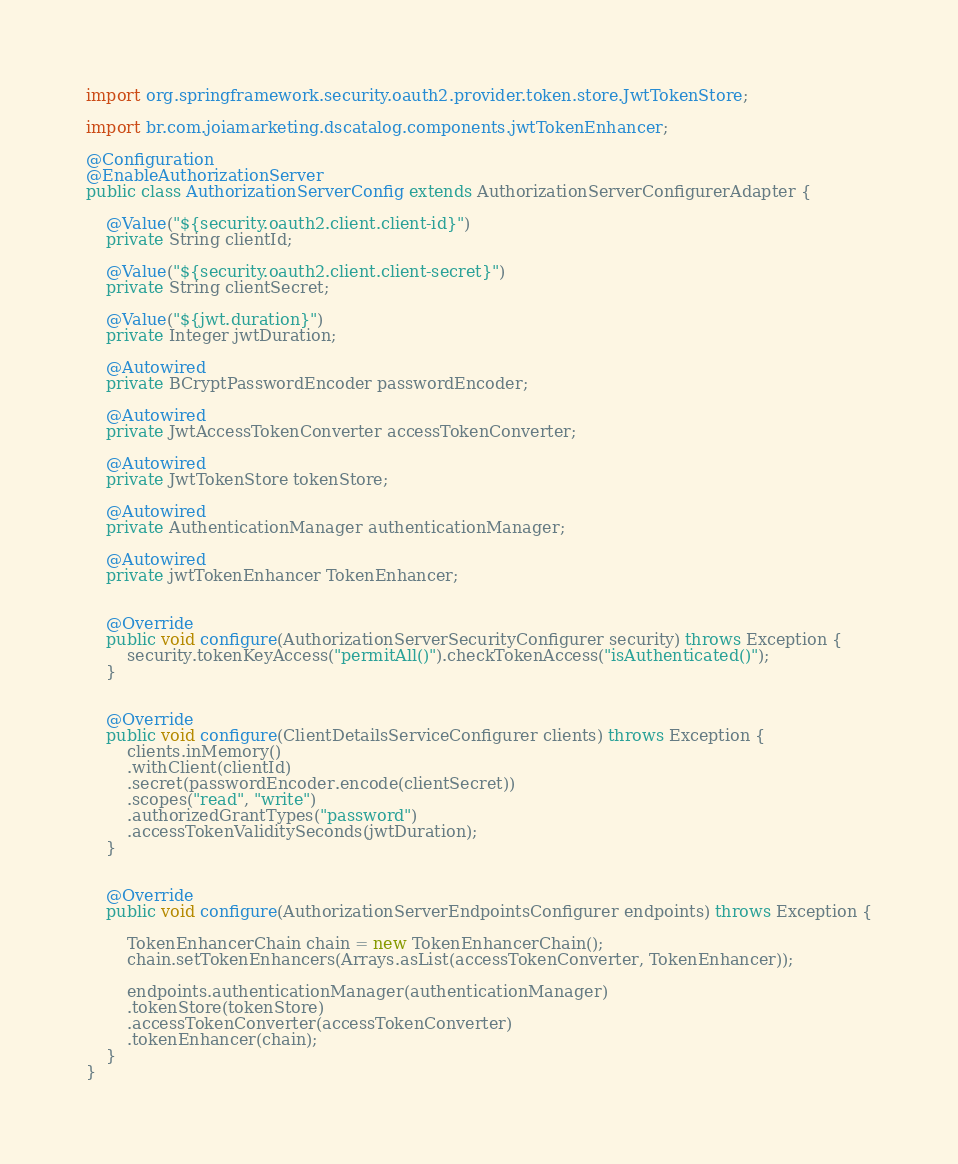Convert code to text. <code><loc_0><loc_0><loc_500><loc_500><_Java_>import org.springframework.security.oauth2.provider.token.store.JwtTokenStore;

import br.com.joiamarketing.dscatalog.components.jwtTokenEnhancer;

@Configuration
@EnableAuthorizationServer
public class AuthorizationServerConfig extends AuthorizationServerConfigurerAdapter {
	
	@Value("${security.oauth2.client.client-id}")
	private String clientId;
	
	@Value("${security.oauth2.client.client-secret}")
	private String clientSecret;
	
	@Value("${jwt.duration}")
	private Integer jwtDuration;
	
	@Autowired
	private BCryptPasswordEncoder passwordEncoder;
	
	@Autowired
	private JwtAccessTokenConverter accessTokenConverter;
	
	@Autowired
	private JwtTokenStore tokenStore;

	@Autowired
	private AuthenticationManager authenticationManager;
	
	@Autowired
	private jwtTokenEnhancer TokenEnhancer;
	
	
	@Override
	public void configure(AuthorizationServerSecurityConfigurer security) throws Exception {
		security.tokenKeyAccess("permitAll()").checkTokenAccess("isAuthenticated()");
	}

	
	@Override
	public void configure(ClientDetailsServiceConfigurer clients) throws Exception {
		clients.inMemory()
		.withClient(clientId)
		.secret(passwordEncoder.encode(clientSecret))
		.scopes("read", "write")
		.authorizedGrantTypes("password")
		.accessTokenValiditySeconds(jwtDuration);
	}
		

	@Override
	public void configure(AuthorizationServerEndpointsConfigurer endpoints) throws Exception {
		
		TokenEnhancerChain chain = new TokenEnhancerChain();
		chain.setTokenEnhancers(Arrays.asList(accessTokenConverter, TokenEnhancer));
		
		endpoints.authenticationManager(authenticationManager)
		.tokenStore(tokenStore)
		.accessTokenConverter(accessTokenConverter)
		.tokenEnhancer(chain);
	}
}
</code> 